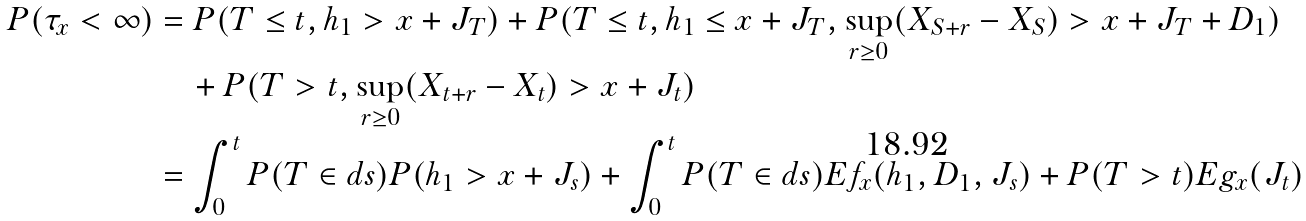<formula> <loc_0><loc_0><loc_500><loc_500>P ( \tau _ { x } < \infty ) & = P ( T \leq t , h _ { 1 } > x + J _ { T } ) + P ( T \leq t , h _ { 1 } \leq x + J _ { T } , \sup _ { r \geq 0 } ( X _ { S + r } - X _ { S } ) > x + J _ { T } + D _ { 1 } ) \\ & \quad + P ( T > t , \sup _ { r \geq 0 } ( X _ { t + r } - X _ { t } ) > x + J _ { t } ) \\ & = \int _ { 0 } ^ { t } P ( T \in d s ) P ( h _ { 1 } > x + J _ { s } ) + \int _ { 0 } ^ { t } P ( T \in d s ) E f _ { x } ( h _ { 1 } , D _ { 1 } , J _ { s } ) + P ( T > t ) E g _ { x } ( J _ { t } ) \\</formula> 